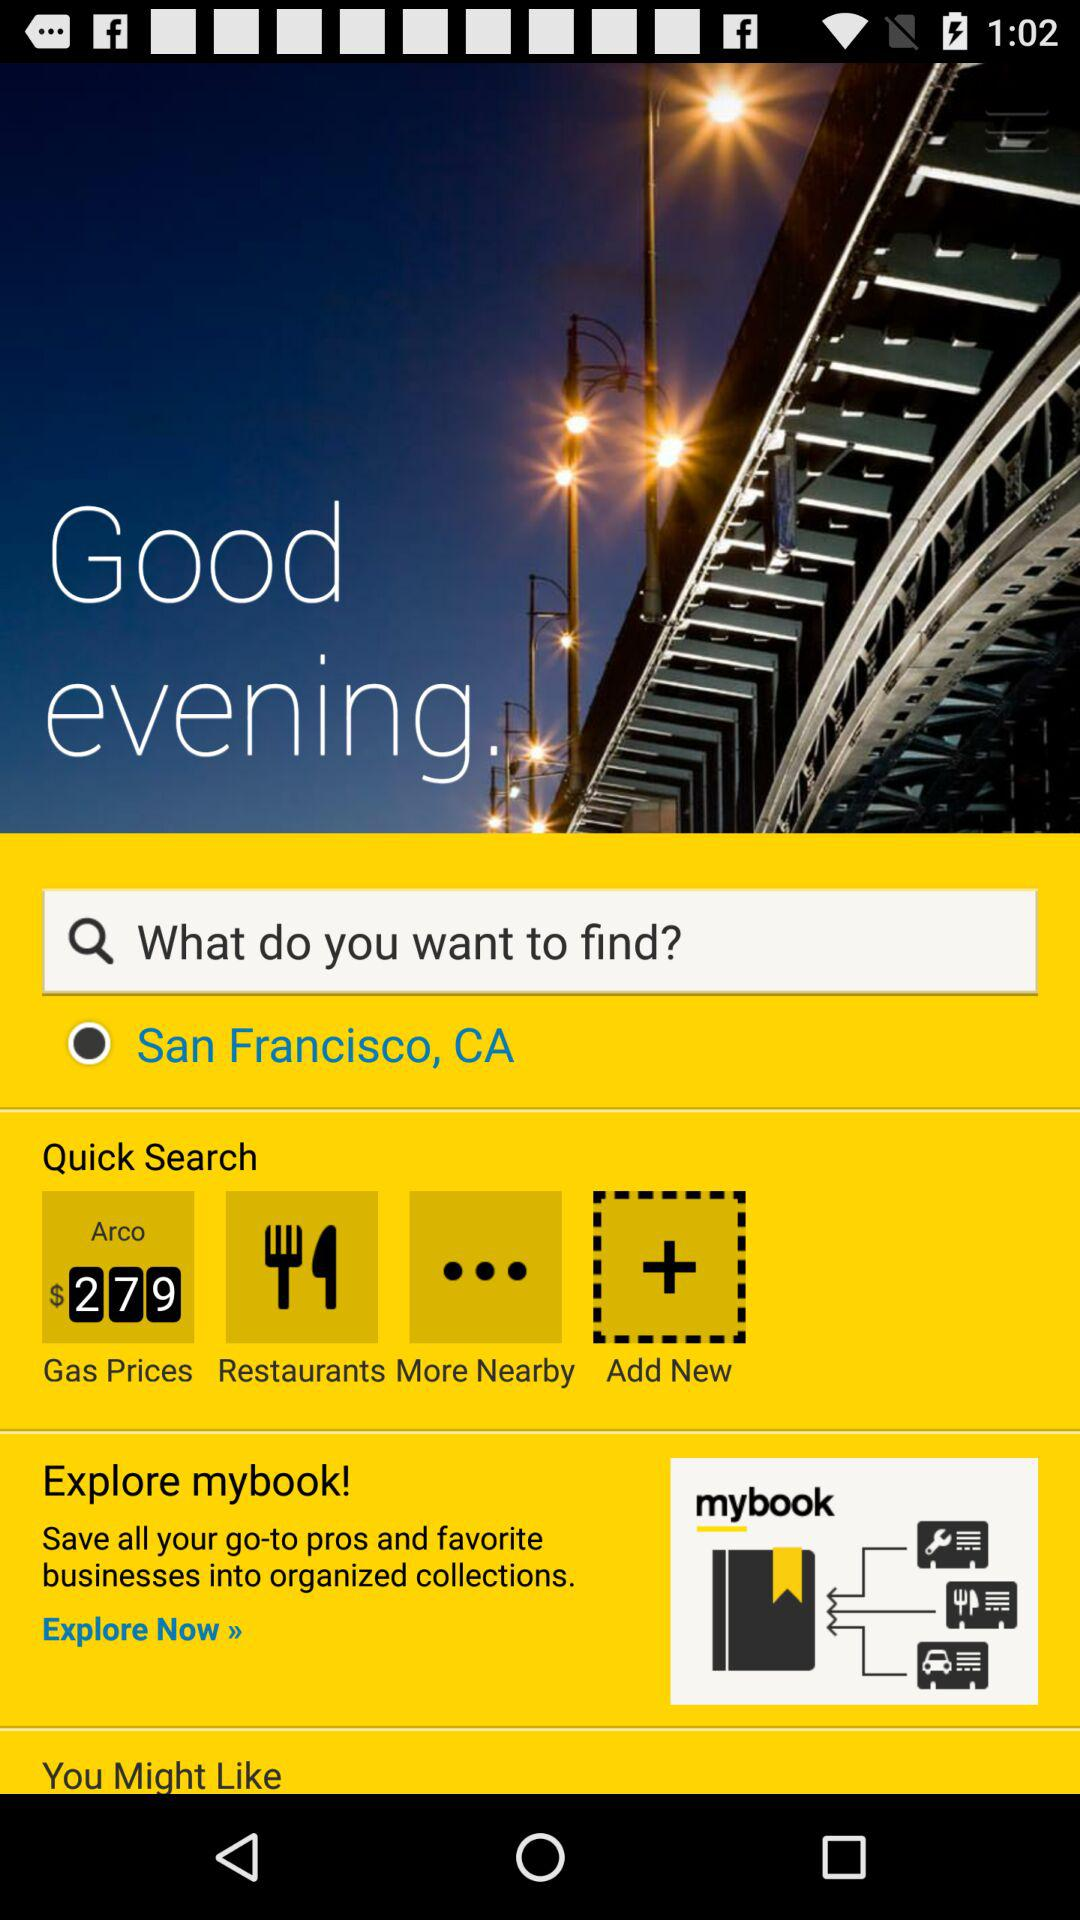In organized collection, what do we save? In an organized collection, you can save go-to pros and favorite businesses. 